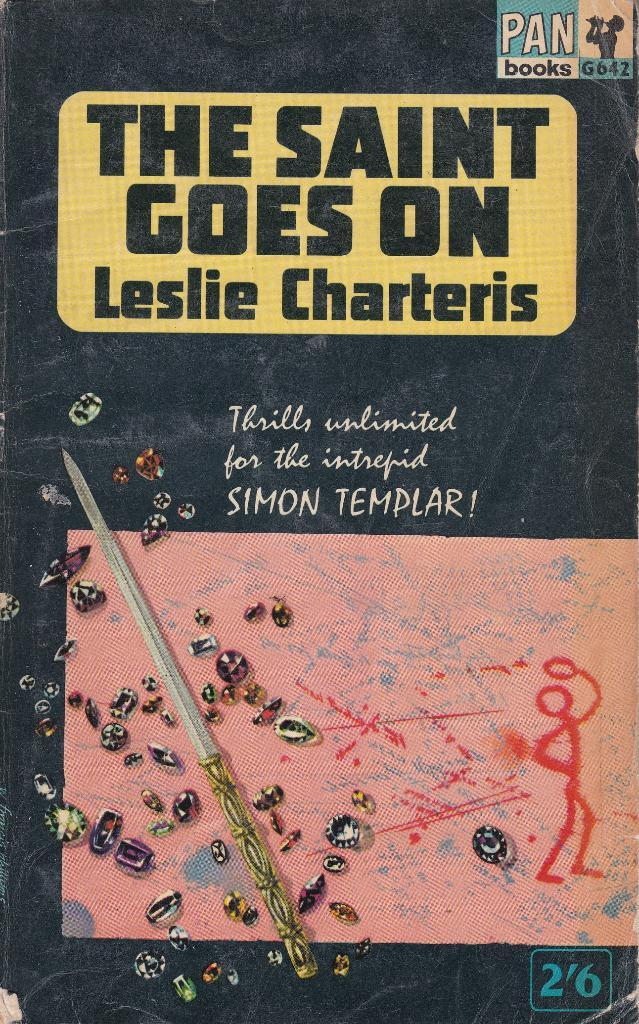<image>
Write a terse but informative summary of the picture. A book by Leslie Charteris which has the title The Saint Goes On contains adventures of Simon Templar. 